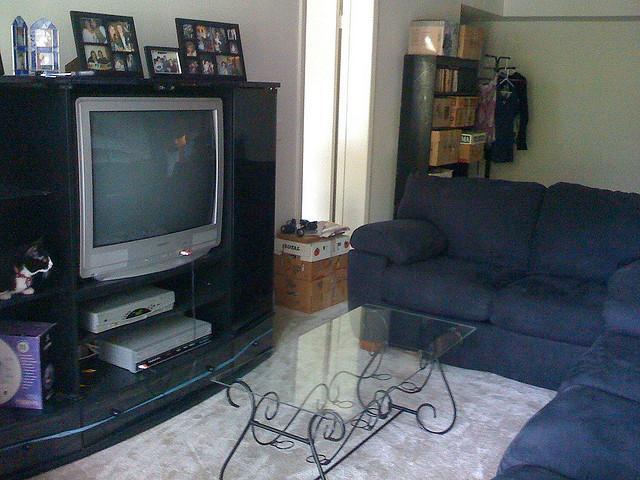How many couches are visible?
Give a very brief answer. 2. 